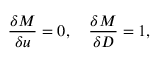Convert formula to latex. <formula><loc_0><loc_0><loc_500><loc_500>\frac { \delta M } { \delta u } = 0 , \quad \frac { \delta M } { \delta D } = 1 ,</formula> 